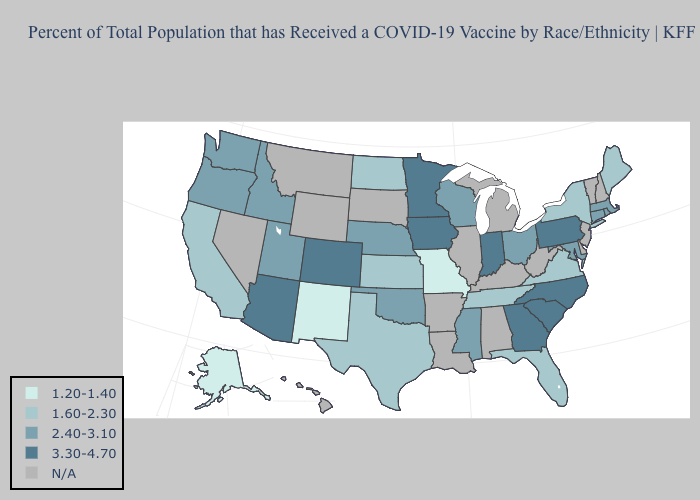Does Pennsylvania have the highest value in the Northeast?
Write a very short answer. Yes. What is the value of New Hampshire?
Keep it brief. N/A. Name the states that have a value in the range 1.20-1.40?
Concise answer only. Alaska, Missouri, New Mexico. Name the states that have a value in the range N/A?
Answer briefly. Alabama, Arkansas, Delaware, Hawaii, Illinois, Kentucky, Louisiana, Michigan, Montana, Nevada, New Hampshire, New Jersey, South Dakota, Vermont, West Virginia, Wyoming. Name the states that have a value in the range 2.40-3.10?
Quick response, please. Connecticut, Idaho, Maryland, Massachusetts, Mississippi, Nebraska, Ohio, Oklahoma, Oregon, Rhode Island, Utah, Washington, Wisconsin. Name the states that have a value in the range 1.20-1.40?
Write a very short answer. Alaska, Missouri, New Mexico. What is the highest value in the Northeast ?
Be succinct. 3.30-4.70. Does Colorado have the lowest value in the USA?
Concise answer only. No. What is the lowest value in the West?
Quick response, please. 1.20-1.40. What is the value of Oklahoma?
Answer briefly. 2.40-3.10. Name the states that have a value in the range N/A?
Quick response, please. Alabama, Arkansas, Delaware, Hawaii, Illinois, Kentucky, Louisiana, Michigan, Montana, Nevada, New Hampshire, New Jersey, South Dakota, Vermont, West Virginia, Wyoming. Name the states that have a value in the range 1.60-2.30?
Write a very short answer. California, Florida, Kansas, Maine, New York, North Dakota, Tennessee, Texas, Virginia. Which states have the highest value in the USA?
Give a very brief answer. Arizona, Colorado, Georgia, Indiana, Iowa, Minnesota, North Carolina, Pennsylvania, South Carolina. Among the states that border Minnesota , which have the lowest value?
Short answer required. North Dakota. 